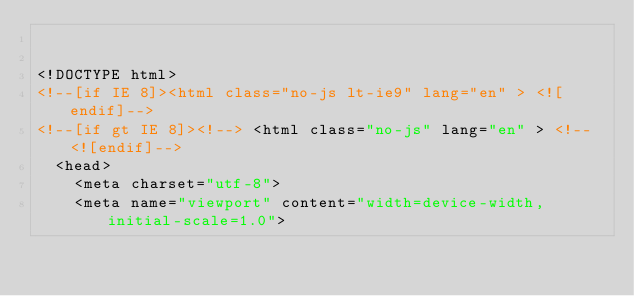<code> <loc_0><loc_0><loc_500><loc_500><_HTML_>

<!DOCTYPE html>
<!--[if IE 8]><html class="no-js lt-ie9" lang="en" > <![endif]-->
<!--[if gt IE 8]><!--> <html class="no-js" lang="en" > <!--<![endif]-->
  <head>
    <meta charset="utf-8">
    <meta name="viewport" content="width=device-width, initial-scale=1.0">
</code> 